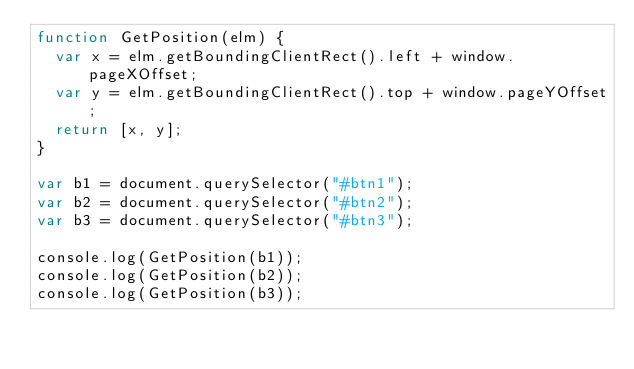<code> <loc_0><loc_0><loc_500><loc_500><_JavaScript_>function GetPosition(elm) {
  var x = elm.getBoundingClientRect().left + window.pageXOffset;
  var y = elm.getBoundingClientRect().top + window.pageYOffset;
  return [x, y];
}

var b1 = document.querySelector("#btn1");
var b2 = document.querySelector("#btn2");
var b3 = document.querySelector("#btn3");

console.log(GetPosition(b1));
console.log(GetPosition(b2));
console.log(GetPosition(b3));
</code> 